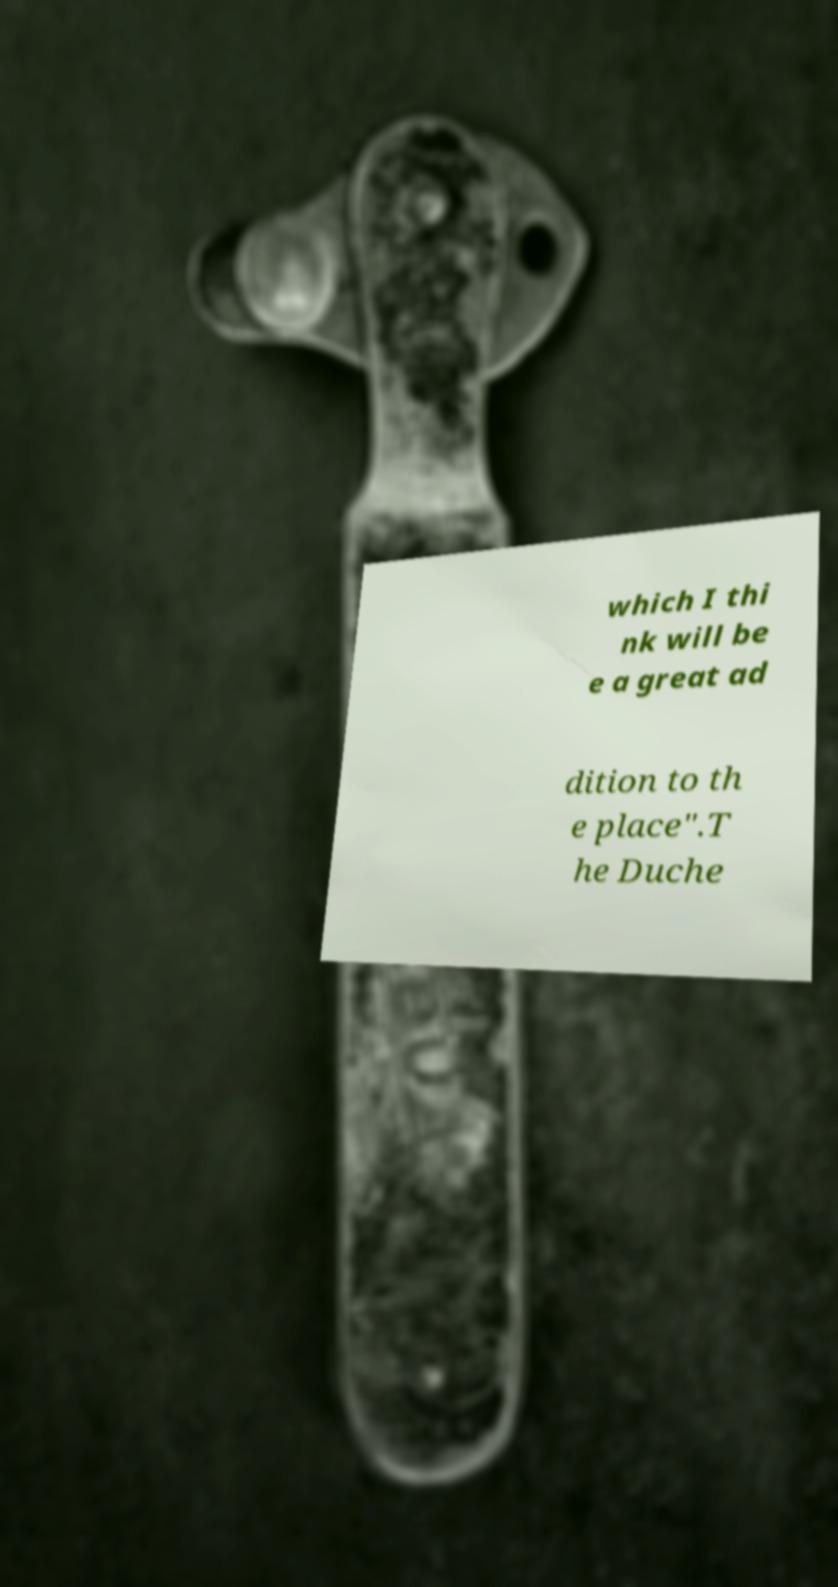What messages or text are displayed in this image? I need them in a readable, typed format. which I thi nk will be e a great ad dition to th e place".T he Duche 